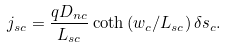<formula> <loc_0><loc_0><loc_500><loc_500>j _ { s c } = \frac { q D _ { n c } } { L _ { s c } } \coth \left ( w _ { c } / L _ { s c } \right ) \delta s _ { c } .</formula> 